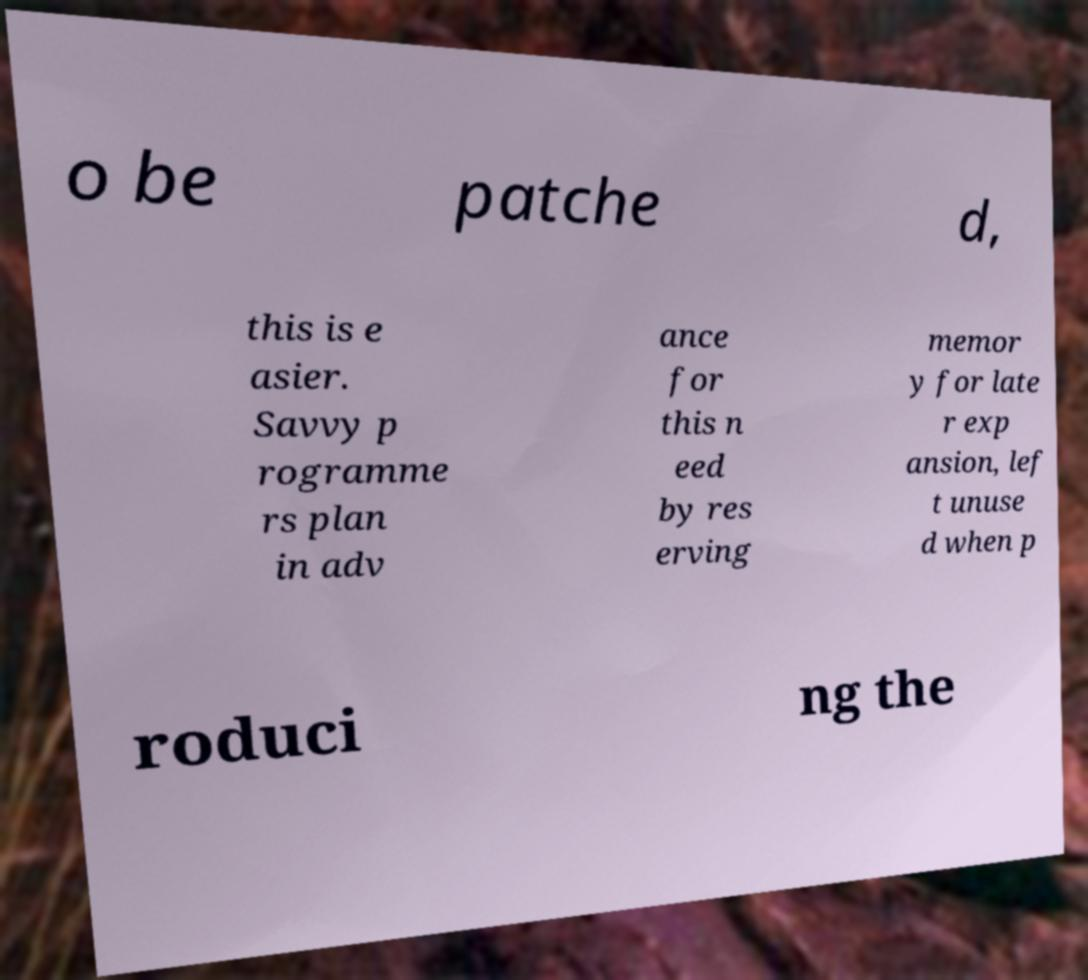Please identify and transcribe the text found in this image. o be patche d, this is e asier. Savvy p rogramme rs plan in adv ance for this n eed by res erving memor y for late r exp ansion, lef t unuse d when p roduci ng the 